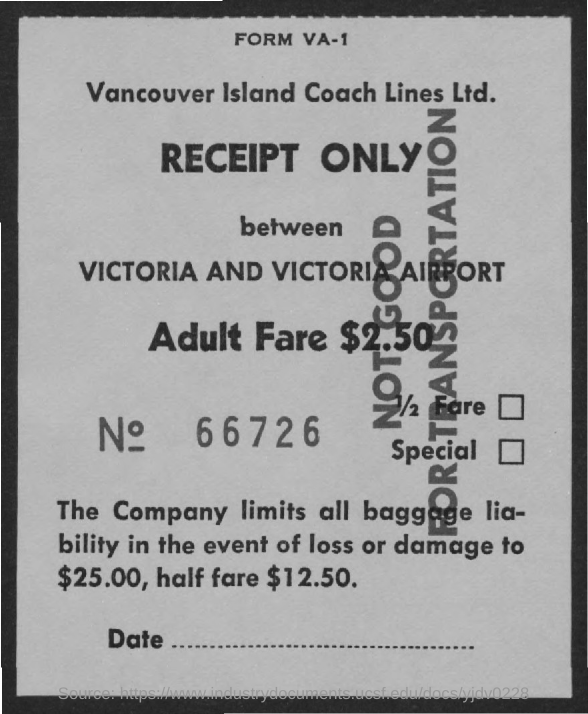Who has issued the receipt?
Ensure brevity in your answer.  Vancouver Island Coach Lines Ltd. What is the number of the receipt?
Ensure brevity in your answer.  66726. How much is Adult Fare ?
Your response must be concise. $2.50. 